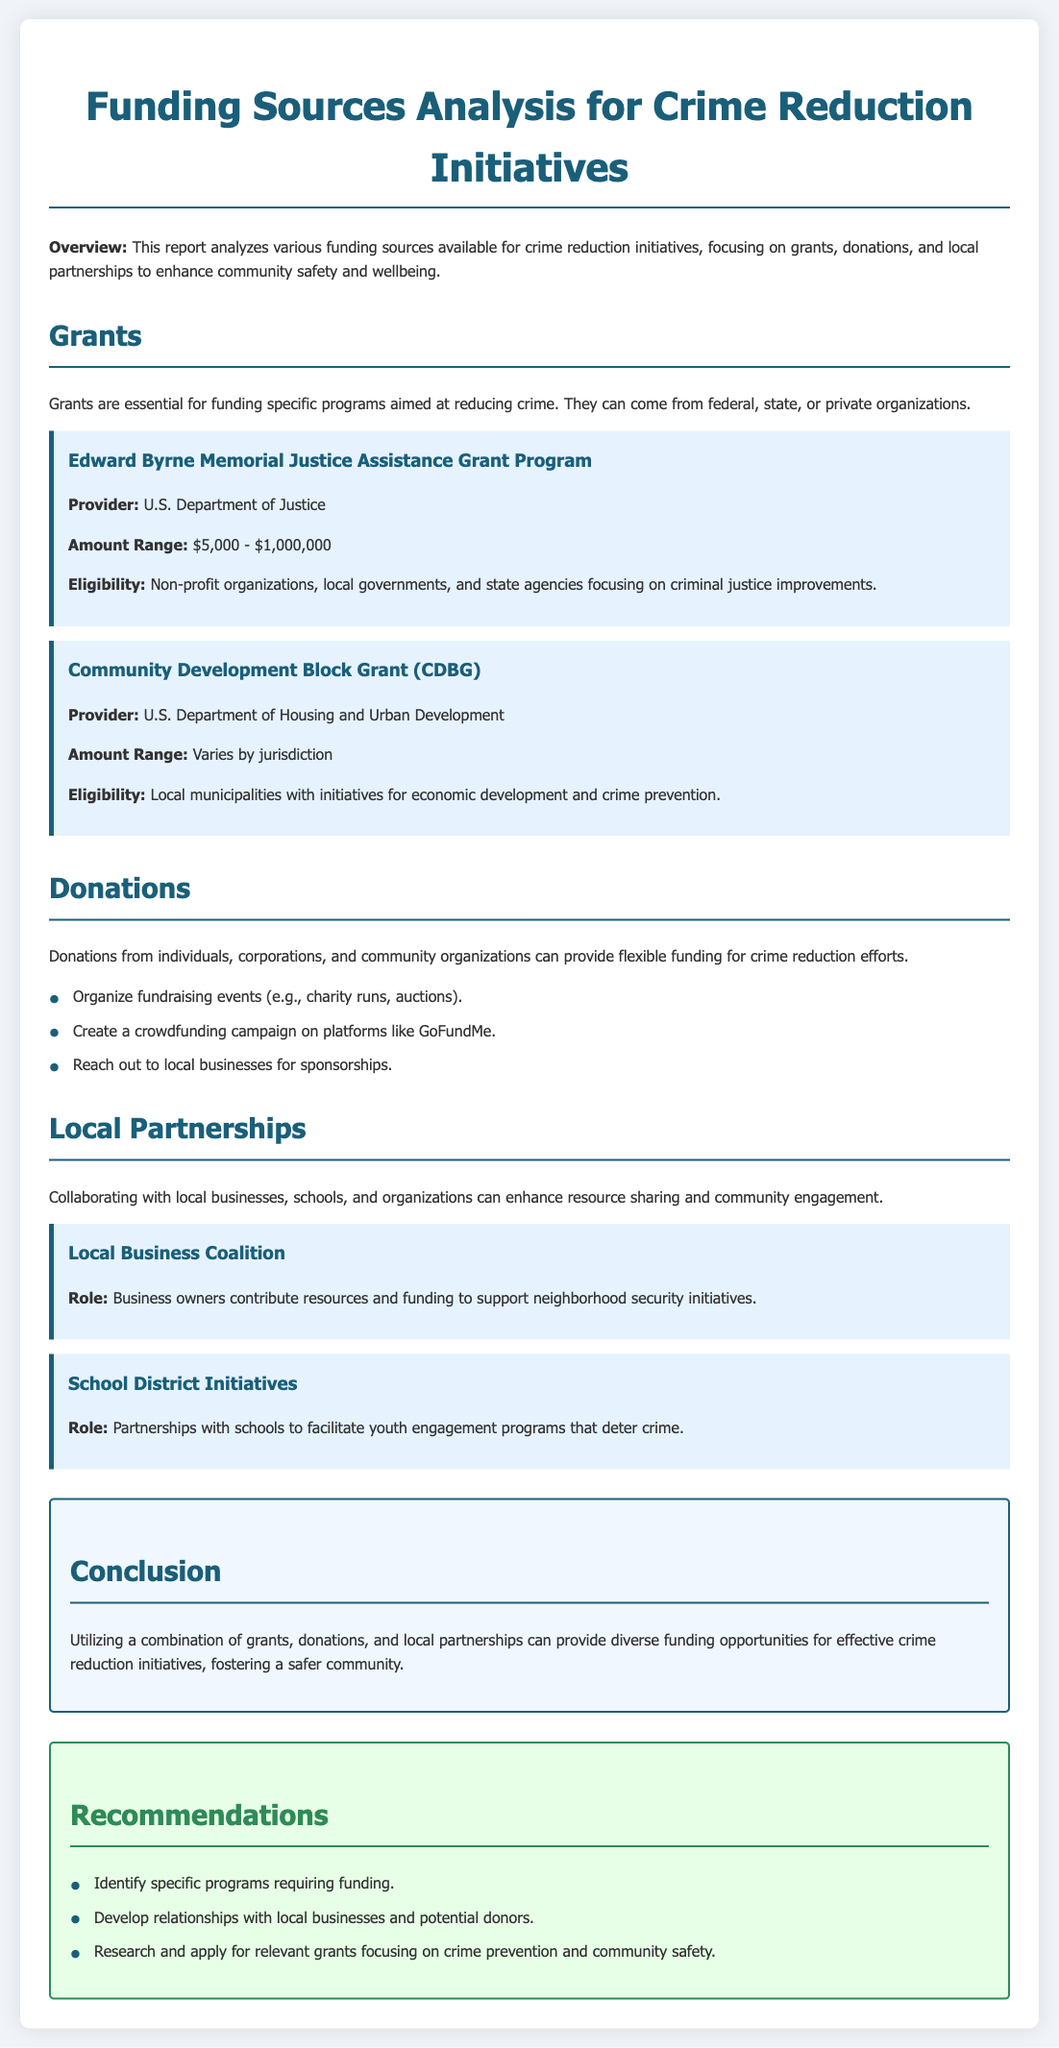What is the title of the report? The title of the report is the main heading of the document, which is "Funding Sources Analysis for Crime Reduction Initiatives."
Answer: Funding Sources Analysis for Crime Reduction Initiatives Who provides the Edward Byrne Memorial Justice Assistance Grant? The provider for this grant is mentioned explicitly in the grant section of the document.
Answer: U.S. Department of Justice What is the amount range for the Edward Byrne Memorial Justice Assistance Grant? This information can be found in the grant details provided in the document.
Answer: $5,000 - $1,000,000 What type of organizations are eligible for the Community Development Block Grant? Eligibility criteria for this grant are outlined within the grant section of the document.
Answer: Local municipalities List one way to generate donations mentioned in the document. The document lists various methods for generating donations; one of them is highlighted in the donations section.
Answer: Organize fundraising events What partnerships are suggested for enhancing crime reduction initiatives? The document mentions certain collaborations that can help in crime reduction, focusing on their roles.
Answer: Local Business Coalition How many grants are analyzed in the report? The number of grants can be determined from the sections highlighting them in the document.
Answer: Two What is the main conclusion regarding funding sources for crime reduction? The conclusion summarizes the findings related to various funding sources in the document.
Answer: Diverse funding opportunities What is one recommendation for seeking funding? Recommendations list strategies that can be employed to secure funds for the initiatives.
Answer: Identify specific programs requiring funding 